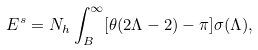<formula> <loc_0><loc_0><loc_500><loc_500>E ^ { s } = N _ { h } \int ^ { \infty } _ { B } [ \theta ( 2 \Lambda - 2 ) - \pi ] \sigma ( \Lambda ) ,</formula> 